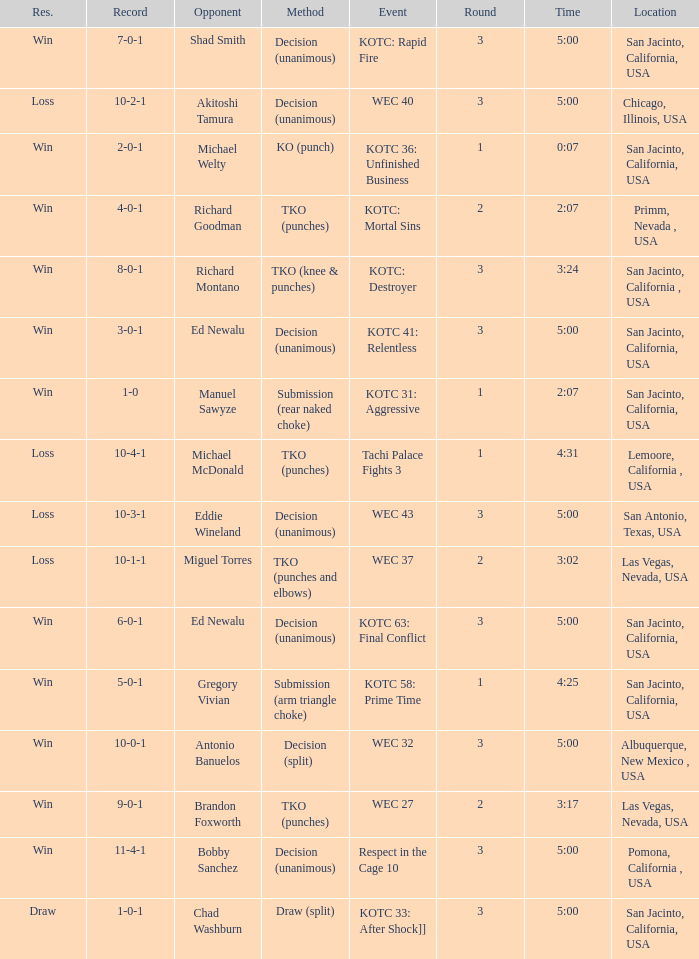What time did the even tachi palace fights 3 take place? 4:31. 